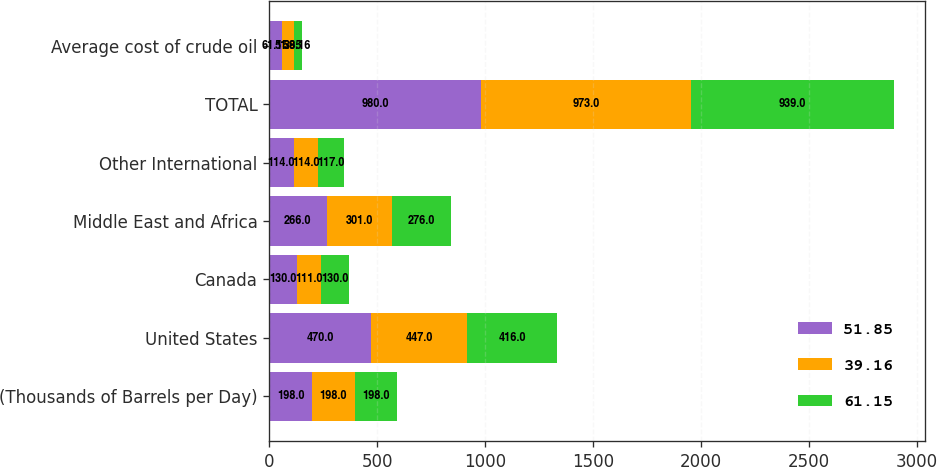Convert chart. <chart><loc_0><loc_0><loc_500><loc_500><stacked_bar_chart><ecel><fcel>(Thousands of Barrels per Day)<fcel>United States<fcel>Canada<fcel>Middle East and Africa<fcel>Other International<fcel>TOTAL<fcel>Average cost of crude oil<nl><fcel>51.85<fcel>198<fcel>470<fcel>130<fcel>266<fcel>114<fcel>980<fcel>61.15<nl><fcel>39.16<fcel>198<fcel>447<fcel>111<fcel>301<fcel>114<fcel>973<fcel>51.85<nl><fcel>61.15<fcel>198<fcel>416<fcel>130<fcel>276<fcel>117<fcel>939<fcel>39.16<nl></chart> 